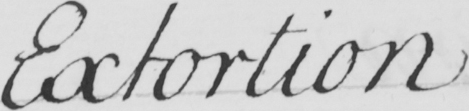Can you read and transcribe this handwriting? Extortion 